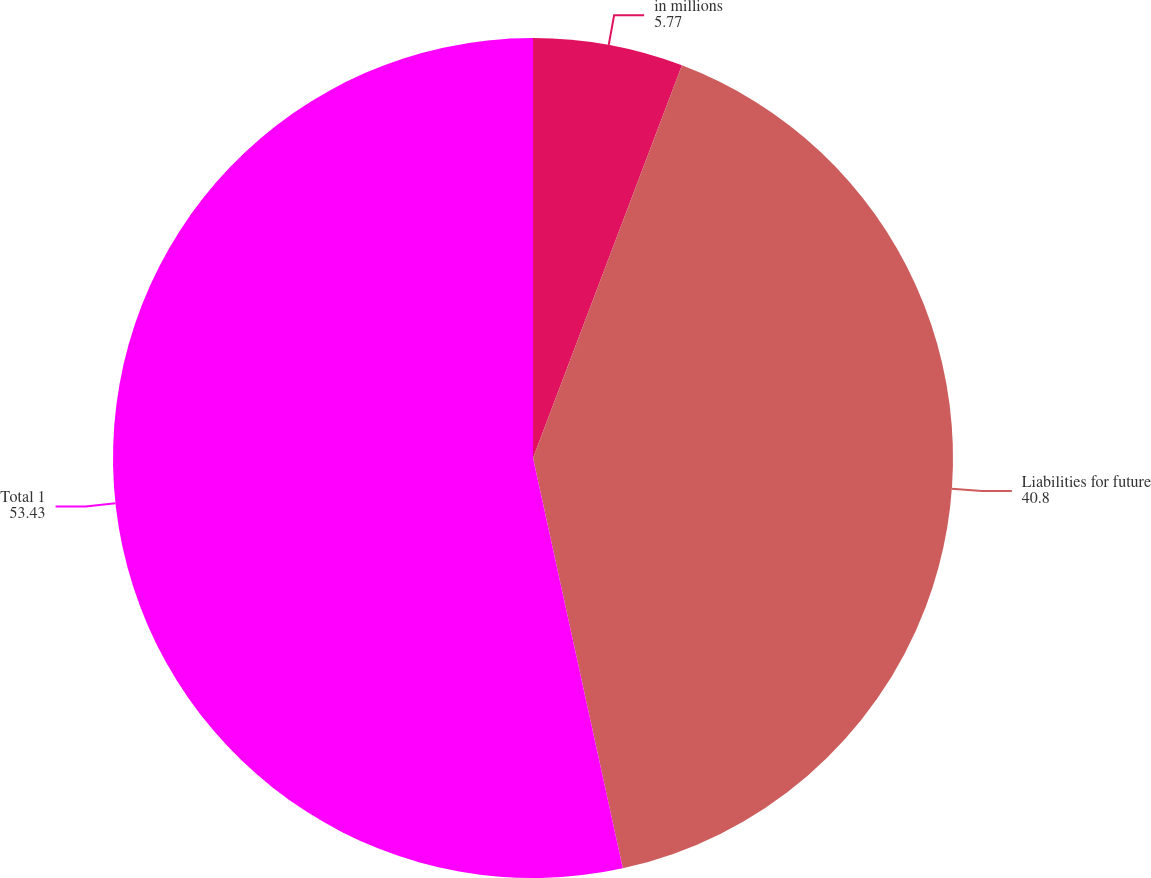Convert chart. <chart><loc_0><loc_0><loc_500><loc_500><pie_chart><fcel>in millions<fcel>Liabilities for future<fcel>Total 1<nl><fcel>5.77%<fcel>40.8%<fcel>53.43%<nl></chart> 